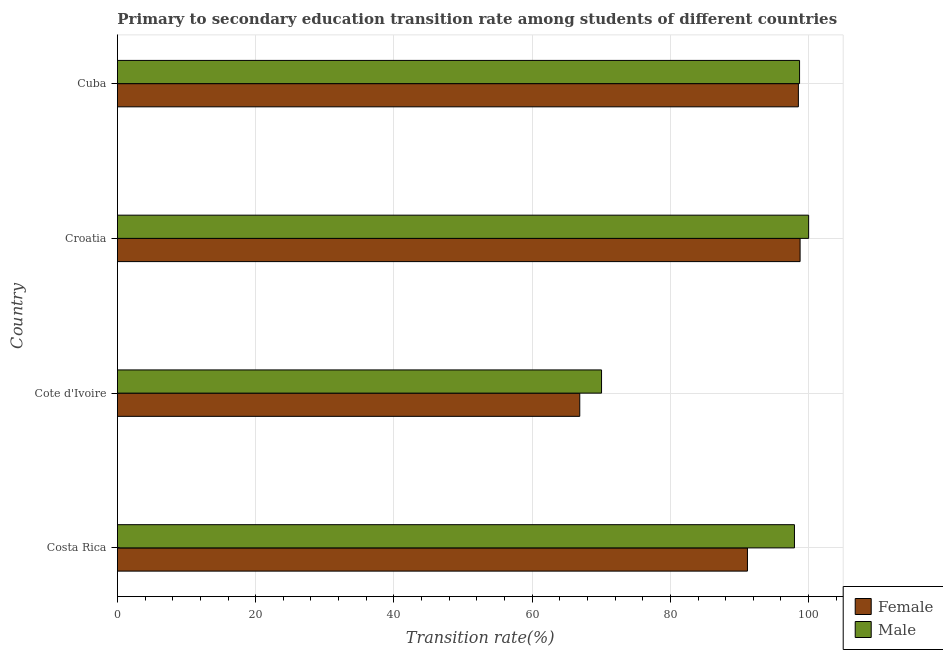How many different coloured bars are there?
Ensure brevity in your answer.  2. How many groups of bars are there?
Offer a terse response. 4. Are the number of bars on each tick of the Y-axis equal?
Provide a succinct answer. Yes. How many bars are there on the 2nd tick from the top?
Keep it short and to the point. 2. What is the label of the 3rd group of bars from the top?
Your answer should be compact. Cote d'Ivoire. Across all countries, what is the maximum transition rate among female students?
Give a very brief answer. 98.77. Across all countries, what is the minimum transition rate among female students?
Provide a succinct answer. 66.89. In which country was the transition rate among male students maximum?
Provide a short and direct response. Croatia. In which country was the transition rate among female students minimum?
Ensure brevity in your answer.  Cote d'Ivoire. What is the total transition rate among female students in the graph?
Offer a terse response. 355.32. What is the difference between the transition rate among female students in Costa Rica and that in Croatia?
Offer a terse response. -7.62. What is the difference between the transition rate among male students in Costa Rica and the transition rate among female students in Cote d'Ivoire?
Your answer should be very brief. 31.06. What is the average transition rate among male students per country?
Your response must be concise. 91.67. What is the difference between the transition rate among male students and transition rate among female students in Cote d'Ivoire?
Give a very brief answer. 3.15. What is the ratio of the transition rate among female students in Costa Rica to that in Cote d'Ivoire?
Your answer should be compact. 1.36. Is the transition rate among male students in Costa Rica less than that in Croatia?
Your answer should be compact. Yes. Is the difference between the transition rate among female students in Costa Rica and Croatia greater than the difference between the transition rate among male students in Costa Rica and Croatia?
Offer a terse response. No. What is the difference between the highest and the second highest transition rate among male students?
Your answer should be compact. 1.31. What is the difference between the highest and the lowest transition rate among female students?
Your answer should be very brief. 31.87. What does the 1st bar from the top in Costa Rica represents?
Your answer should be compact. Male. Are all the bars in the graph horizontal?
Give a very brief answer. Yes. How many countries are there in the graph?
Keep it short and to the point. 4. What is the difference between two consecutive major ticks on the X-axis?
Give a very brief answer. 20. Are the values on the major ticks of X-axis written in scientific E-notation?
Offer a very short reply. No. Does the graph contain any zero values?
Provide a short and direct response. No. How many legend labels are there?
Give a very brief answer. 2. How are the legend labels stacked?
Your answer should be very brief. Vertical. What is the title of the graph?
Provide a short and direct response. Primary to secondary education transition rate among students of different countries. Does "Attending school" appear as one of the legend labels in the graph?
Make the answer very short. No. What is the label or title of the X-axis?
Provide a succinct answer. Transition rate(%). What is the label or title of the Y-axis?
Keep it short and to the point. Country. What is the Transition rate(%) of Female in Costa Rica?
Your answer should be very brief. 91.15. What is the Transition rate(%) of Male in Costa Rica?
Provide a succinct answer. 97.95. What is the Transition rate(%) in Female in Cote d'Ivoire?
Your answer should be compact. 66.89. What is the Transition rate(%) of Male in Cote d'Ivoire?
Offer a terse response. 70.04. What is the Transition rate(%) of Female in Croatia?
Provide a succinct answer. 98.77. What is the Transition rate(%) of Male in Croatia?
Your response must be concise. 100. What is the Transition rate(%) of Female in Cuba?
Your answer should be compact. 98.52. What is the Transition rate(%) in Male in Cuba?
Offer a very short reply. 98.69. Across all countries, what is the maximum Transition rate(%) of Female?
Your answer should be very brief. 98.77. Across all countries, what is the minimum Transition rate(%) in Female?
Provide a succinct answer. 66.89. Across all countries, what is the minimum Transition rate(%) in Male?
Keep it short and to the point. 70.04. What is the total Transition rate(%) in Female in the graph?
Your answer should be compact. 355.32. What is the total Transition rate(%) of Male in the graph?
Give a very brief answer. 366.68. What is the difference between the Transition rate(%) in Female in Costa Rica and that in Cote d'Ivoire?
Your response must be concise. 24.26. What is the difference between the Transition rate(%) of Male in Costa Rica and that in Cote d'Ivoire?
Provide a short and direct response. 27.91. What is the difference between the Transition rate(%) in Female in Costa Rica and that in Croatia?
Provide a short and direct response. -7.62. What is the difference between the Transition rate(%) of Male in Costa Rica and that in Croatia?
Provide a short and direct response. -2.05. What is the difference between the Transition rate(%) in Female in Costa Rica and that in Cuba?
Provide a succinct answer. -7.37. What is the difference between the Transition rate(%) of Male in Costa Rica and that in Cuba?
Your answer should be compact. -0.74. What is the difference between the Transition rate(%) of Female in Cote d'Ivoire and that in Croatia?
Provide a succinct answer. -31.87. What is the difference between the Transition rate(%) in Male in Cote d'Ivoire and that in Croatia?
Provide a short and direct response. -29.96. What is the difference between the Transition rate(%) in Female in Cote d'Ivoire and that in Cuba?
Your answer should be very brief. -31.62. What is the difference between the Transition rate(%) in Male in Cote d'Ivoire and that in Cuba?
Give a very brief answer. -28.65. What is the difference between the Transition rate(%) of Female in Croatia and that in Cuba?
Your answer should be compact. 0.25. What is the difference between the Transition rate(%) in Male in Croatia and that in Cuba?
Ensure brevity in your answer.  1.31. What is the difference between the Transition rate(%) in Female in Costa Rica and the Transition rate(%) in Male in Cote d'Ivoire?
Offer a very short reply. 21.11. What is the difference between the Transition rate(%) of Female in Costa Rica and the Transition rate(%) of Male in Croatia?
Offer a very short reply. -8.85. What is the difference between the Transition rate(%) of Female in Costa Rica and the Transition rate(%) of Male in Cuba?
Give a very brief answer. -7.54. What is the difference between the Transition rate(%) of Female in Cote d'Ivoire and the Transition rate(%) of Male in Croatia?
Offer a very short reply. -33.11. What is the difference between the Transition rate(%) in Female in Cote d'Ivoire and the Transition rate(%) in Male in Cuba?
Your response must be concise. -31.8. What is the difference between the Transition rate(%) in Female in Croatia and the Transition rate(%) in Male in Cuba?
Offer a very short reply. 0.08. What is the average Transition rate(%) of Female per country?
Offer a very short reply. 88.83. What is the average Transition rate(%) of Male per country?
Provide a short and direct response. 91.67. What is the difference between the Transition rate(%) in Female and Transition rate(%) in Male in Costa Rica?
Offer a terse response. -6.8. What is the difference between the Transition rate(%) of Female and Transition rate(%) of Male in Cote d'Ivoire?
Provide a succinct answer. -3.15. What is the difference between the Transition rate(%) of Female and Transition rate(%) of Male in Croatia?
Give a very brief answer. -1.24. What is the difference between the Transition rate(%) of Female and Transition rate(%) of Male in Cuba?
Your answer should be compact. -0.17. What is the ratio of the Transition rate(%) in Female in Costa Rica to that in Cote d'Ivoire?
Provide a short and direct response. 1.36. What is the ratio of the Transition rate(%) of Male in Costa Rica to that in Cote d'Ivoire?
Offer a terse response. 1.4. What is the ratio of the Transition rate(%) in Female in Costa Rica to that in Croatia?
Your answer should be compact. 0.92. What is the ratio of the Transition rate(%) in Male in Costa Rica to that in Croatia?
Keep it short and to the point. 0.98. What is the ratio of the Transition rate(%) of Female in Costa Rica to that in Cuba?
Give a very brief answer. 0.93. What is the ratio of the Transition rate(%) of Male in Costa Rica to that in Cuba?
Your answer should be compact. 0.99. What is the ratio of the Transition rate(%) of Female in Cote d'Ivoire to that in Croatia?
Ensure brevity in your answer.  0.68. What is the ratio of the Transition rate(%) in Male in Cote d'Ivoire to that in Croatia?
Your response must be concise. 0.7. What is the ratio of the Transition rate(%) in Female in Cote d'Ivoire to that in Cuba?
Make the answer very short. 0.68. What is the ratio of the Transition rate(%) in Male in Cote d'Ivoire to that in Cuba?
Provide a short and direct response. 0.71. What is the ratio of the Transition rate(%) in Male in Croatia to that in Cuba?
Provide a succinct answer. 1.01. What is the difference between the highest and the second highest Transition rate(%) of Female?
Provide a succinct answer. 0.25. What is the difference between the highest and the second highest Transition rate(%) in Male?
Provide a short and direct response. 1.31. What is the difference between the highest and the lowest Transition rate(%) in Female?
Your answer should be very brief. 31.87. What is the difference between the highest and the lowest Transition rate(%) of Male?
Provide a succinct answer. 29.96. 